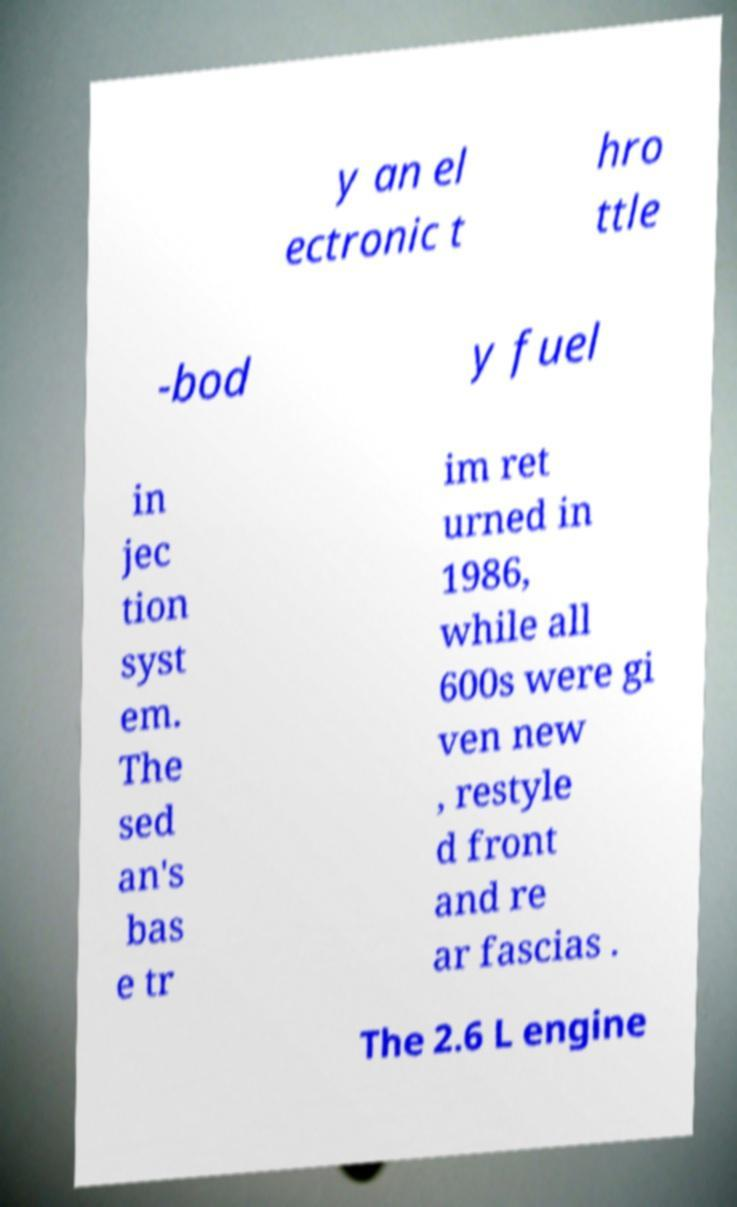What messages or text are displayed in this image? I need them in a readable, typed format. y an el ectronic t hro ttle -bod y fuel in jec tion syst em. The sed an's bas e tr im ret urned in 1986, while all 600s were gi ven new , restyle d front and re ar fascias . The 2.6 L engine 